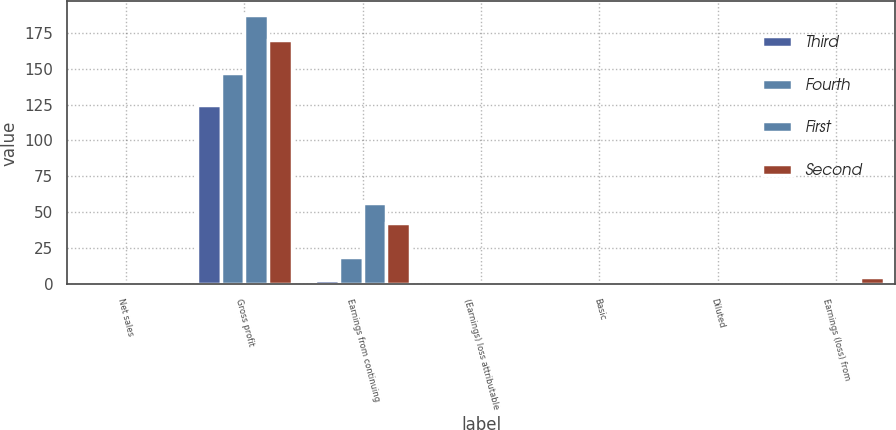Convert chart. <chart><loc_0><loc_0><loc_500><loc_500><stacked_bar_chart><ecel><fcel>Net sales<fcel>Gross profit<fcel>Earnings from continuing<fcel>(Earnings) loss attributable<fcel>Basic<fcel>Diluted<fcel>Earnings (loss) from<nl><fcel>Third<fcel>1.65<fcel>125<fcel>3.3<fcel>0.3<fcel>0.02<fcel>0.02<fcel>0.3<nl><fcel>Fourth<fcel>1.65<fcel>147.2<fcel>19.1<fcel>0.2<fcel>0.12<fcel>0.12<fcel>0.1<nl><fcel>First<fcel>1.65<fcel>187.3<fcel>56.2<fcel>1.4<fcel>0.34<fcel>0.34<fcel>0.5<nl><fcel>Second<fcel>1.65<fcel>170.2<fcel>42.5<fcel>1.9<fcel>0.26<fcel>0.26<fcel>5.4<nl></chart> 